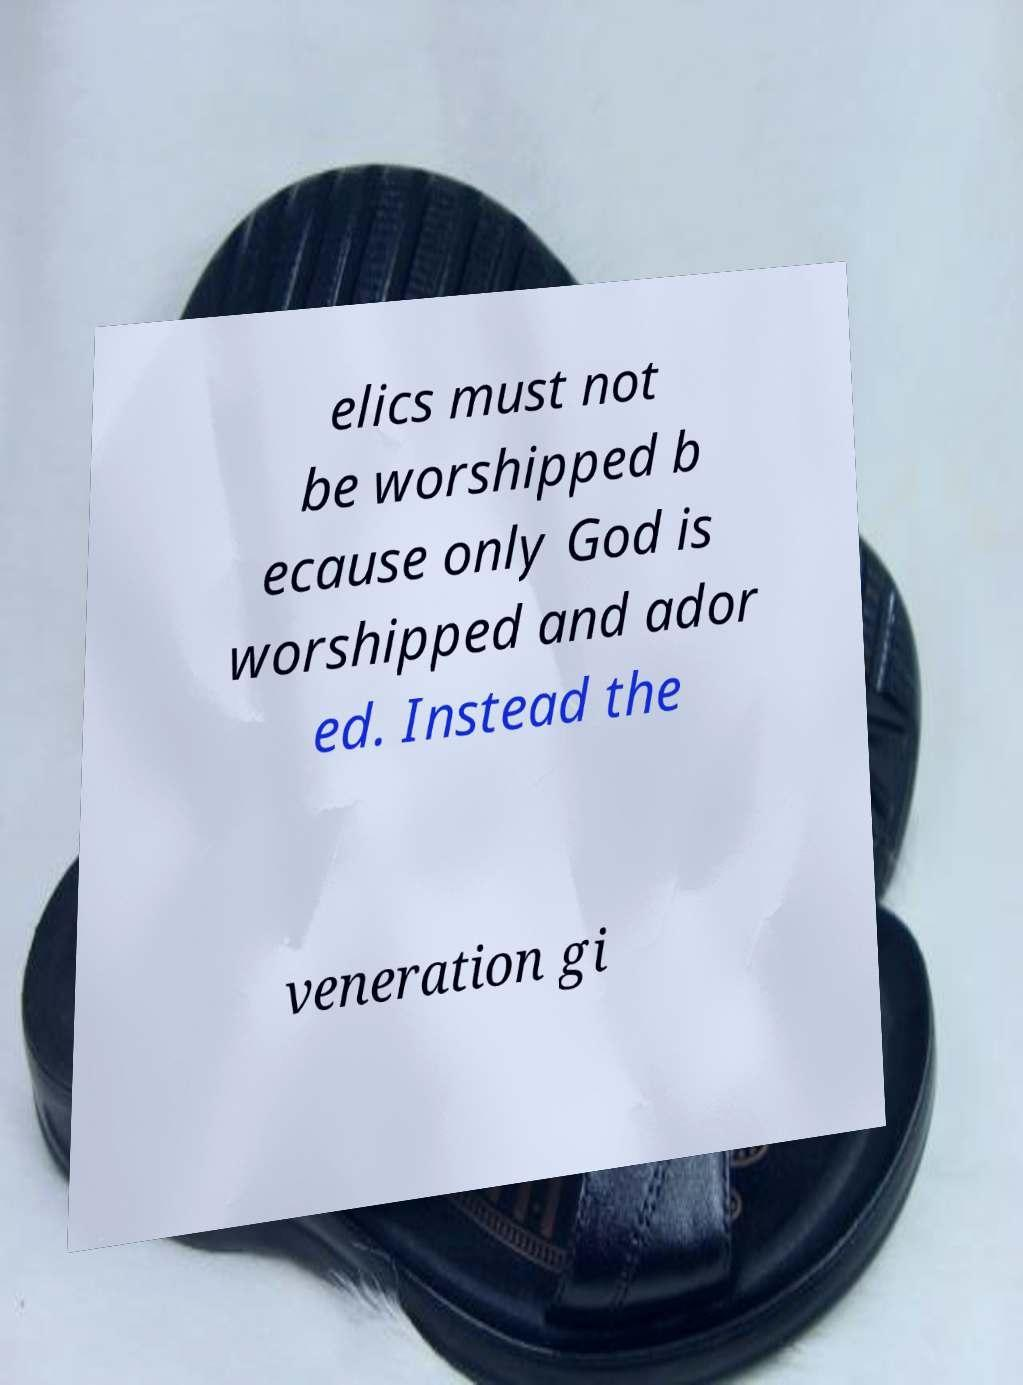There's text embedded in this image that I need extracted. Can you transcribe it verbatim? elics must not be worshipped b ecause only God is worshipped and ador ed. Instead the veneration gi 